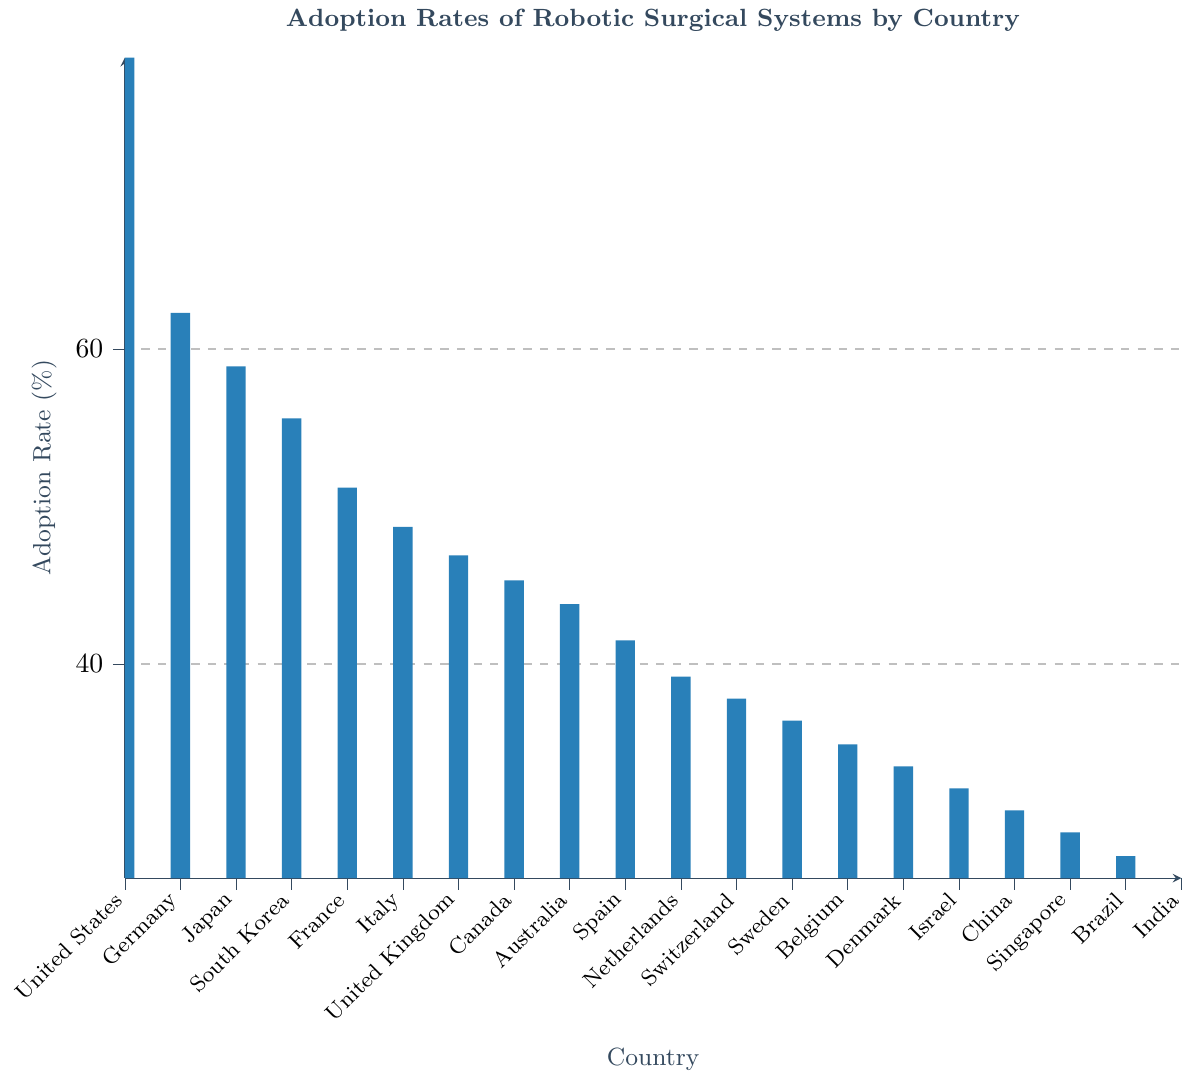What country has the highest adoption rate of robotic surgical systems? The highest bar in the chart represents the country with the highest adoption rate, which is the United States.
Answer: United States What is the difference in adoption rates between Japan and Germany? The adoption rate for Japan is 58.9% and for Germany is 62.3%. The difference is 62.3% - 58.9% = 3.4%.
Answer: 3.4% Which country has a higher adoption rate, South Korea or France? By comparing the heights of the bars, South Korea has a higher adoption rate (55.6%) than France (51.2%).
Answer: South Korea What is the average adoption rate of robotic surgical systems for Italy, Spain, and Netherlands? The adoption rates are: Italy (48.7%), Spain (41.5%), Netherlands (39.2%). The average is calculated as (48.7 + 41.5 + 39.2) / 3 = 43.1%.
Answer: 43.1% Between which two consecutive countries is there the largest drop in adoption rates? By visually inspecting the bar heights, the largest drop is between the United States (78.5%) and Germany (62.3%), which is 78.5% - 62.3% = 16.2%.
Answer: United States and Germany How does the adoption rate in Canada compare to that in Australia? By comparing the bars, Canada's adoption rate (45.3%) is slightly higher than Australia's (43.8%).
Answer: Canada Which country has the lowest adoption rate of robotic surgical systems? The shortest bar in the chart represents the country with the lowest adoption rate, which is India.
Answer: India What is the total adoption rate for four countries: United Kingdom, China, Singapore, and Brazil? The adoption rates are: United Kingdom (46.9%), China (30.7%), Singapore (29.3%), Brazil (27.8%). The total is 46.9% + 30.7% + 29.3% + 27.8% = 134.7%.
Answer: 134.7% What percentage of countries have an adoption rate of above 50%? There are 20 countries in total. The countries with an adoption rate above 50% are: United States, Germany, Japan, South Korea, and France. That's 5 countries. The percentage is (5 / 20) * 100% = 25%.
Answer: 25% Is the adoption rate of robotic surgical systems in Israel above or below the overall average adoption rate? First, calculate the overall average adoption rate. Sum all rates and divide by the number of countries: (78.5 + 62.3 + 58.9 + 55.6 + 51.2 + 48.7 + 46.9 + 45.3 + 43.8 + 41.5 + 39.2 + 37.8 + 36.4 + 34.9 + 33.5 + 32.1 + 30.7 + 29.3 + 27.8 + 26.4) / 20 ≈ 43.8%. Israel's adoption rate is 32.1%, which is below the average.
Answer: Below 